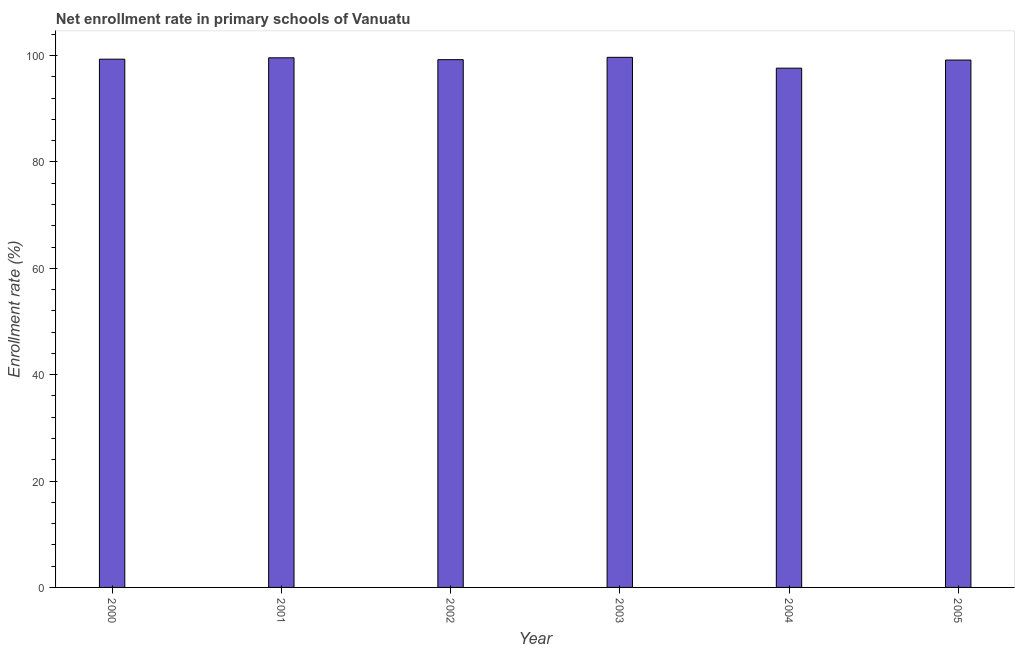Does the graph contain grids?
Keep it short and to the point. No. What is the title of the graph?
Your answer should be compact. Net enrollment rate in primary schools of Vanuatu. What is the label or title of the Y-axis?
Provide a succinct answer. Enrollment rate (%). What is the net enrollment rate in primary schools in 2001?
Make the answer very short. 99.58. Across all years, what is the maximum net enrollment rate in primary schools?
Offer a very short reply. 99.67. Across all years, what is the minimum net enrollment rate in primary schools?
Offer a terse response. 97.63. In which year was the net enrollment rate in primary schools minimum?
Offer a terse response. 2004. What is the sum of the net enrollment rate in primary schools?
Ensure brevity in your answer.  594.57. What is the difference between the net enrollment rate in primary schools in 2002 and 2003?
Your response must be concise. -0.44. What is the average net enrollment rate in primary schools per year?
Your answer should be compact. 99.09. What is the median net enrollment rate in primary schools?
Your answer should be compact. 99.27. In how many years, is the net enrollment rate in primary schools greater than 52 %?
Your answer should be compact. 6. Do a majority of the years between 2002 and 2001 (inclusive) have net enrollment rate in primary schools greater than 64 %?
Offer a terse response. No. Is the net enrollment rate in primary schools in 2003 less than that in 2004?
Give a very brief answer. No. Is the difference between the net enrollment rate in primary schools in 2003 and 2005 greater than the difference between any two years?
Keep it short and to the point. No. What is the difference between the highest and the second highest net enrollment rate in primary schools?
Your answer should be very brief. 0.09. What is the difference between the highest and the lowest net enrollment rate in primary schools?
Your answer should be very brief. 2.04. In how many years, is the net enrollment rate in primary schools greater than the average net enrollment rate in primary schools taken over all years?
Keep it short and to the point. 5. Are the values on the major ticks of Y-axis written in scientific E-notation?
Offer a very short reply. No. What is the Enrollment rate (%) in 2000?
Your answer should be compact. 99.32. What is the Enrollment rate (%) of 2001?
Your answer should be very brief. 99.58. What is the Enrollment rate (%) in 2002?
Provide a short and direct response. 99.23. What is the Enrollment rate (%) in 2003?
Provide a short and direct response. 99.67. What is the Enrollment rate (%) in 2004?
Offer a very short reply. 97.63. What is the Enrollment rate (%) of 2005?
Give a very brief answer. 99.15. What is the difference between the Enrollment rate (%) in 2000 and 2001?
Your response must be concise. -0.26. What is the difference between the Enrollment rate (%) in 2000 and 2002?
Provide a succinct answer. 0.09. What is the difference between the Enrollment rate (%) in 2000 and 2003?
Ensure brevity in your answer.  -0.35. What is the difference between the Enrollment rate (%) in 2000 and 2004?
Offer a terse response. 1.69. What is the difference between the Enrollment rate (%) in 2000 and 2005?
Provide a short and direct response. 0.17. What is the difference between the Enrollment rate (%) in 2001 and 2002?
Provide a succinct answer. 0.35. What is the difference between the Enrollment rate (%) in 2001 and 2003?
Provide a succinct answer. -0.09. What is the difference between the Enrollment rate (%) in 2001 and 2004?
Provide a short and direct response. 1.95. What is the difference between the Enrollment rate (%) in 2001 and 2005?
Keep it short and to the point. 0.42. What is the difference between the Enrollment rate (%) in 2002 and 2003?
Give a very brief answer. -0.44. What is the difference between the Enrollment rate (%) in 2002 and 2004?
Provide a short and direct response. 1.6. What is the difference between the Enrollment rate (%) in 2002 and 2005?
Your answer should be very brief. 0.07. What is the difference between the Enrollment rate (%) in 2003 and 2004?
Provide a short and direct response. 2.04. What is the difference between the Enrollment rate (%) in 2003 and 2005?
Keep it short and to the point. 0.51. What is the difference between the Enrollment rate (%) in 2004 and 2005?
Offer a terse response. -1.52. What is the ratio of the Enrollment rate (%) in 2000 to that in 2002?
Ensure brevity in your answer.  1. What is the ratio of the Enrollment rate (%) in 2000 to that in 2003?
Your answer should be compact. 1. What is the ratio of the Enrollment rate (%) in 2000 to that in 2005?
Your answer should be very brief. 1. What is the ratio of the Enrollment rate (%) in 2001 to that in 2002?
Your answer should be compact. 1. What is the ratio of the Enrollment rate (%) in 2001 to that in 2003?
Keep it short and to the point. 1. What is the ratio of the Enrollment rate (%) in 2001 to that in 2004?
Keep it short and to the point. 1.02. What is the ratio of the Enrollment rate (%) in 2001 to that in 2005?
Offer a very short reply. 1. What is the ratio of the Enrollment rate (%) in 2002 to that in 2004?
Your answer should be compact. 1.02. What is the ratio of the Enrollment rate (%) in 2002 to that in 2005?
Offer a terse response. 1. 